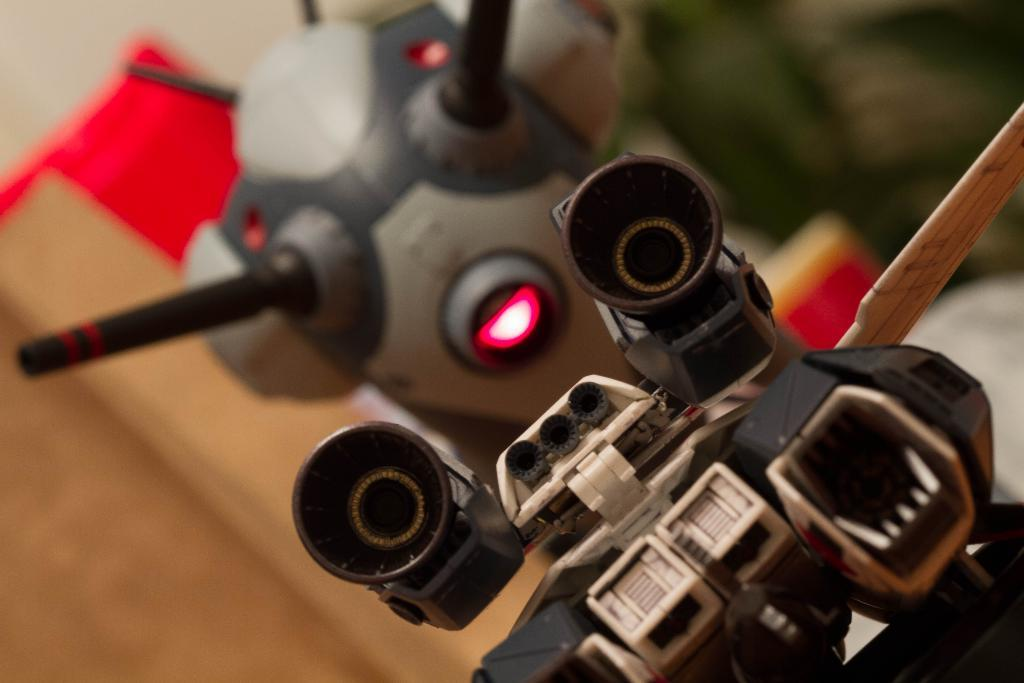What is the main subject of the image? There are two toys in the center of the image. Can you describe the background of the image? The background of the image is blurred. How many flowers are present in the image? There are no flowers visible in the image; it features two toys in the center and a blurred background. What is the chance of finding a feather in the image? There is no feather present in the image, so the chance of finding one is zero. 